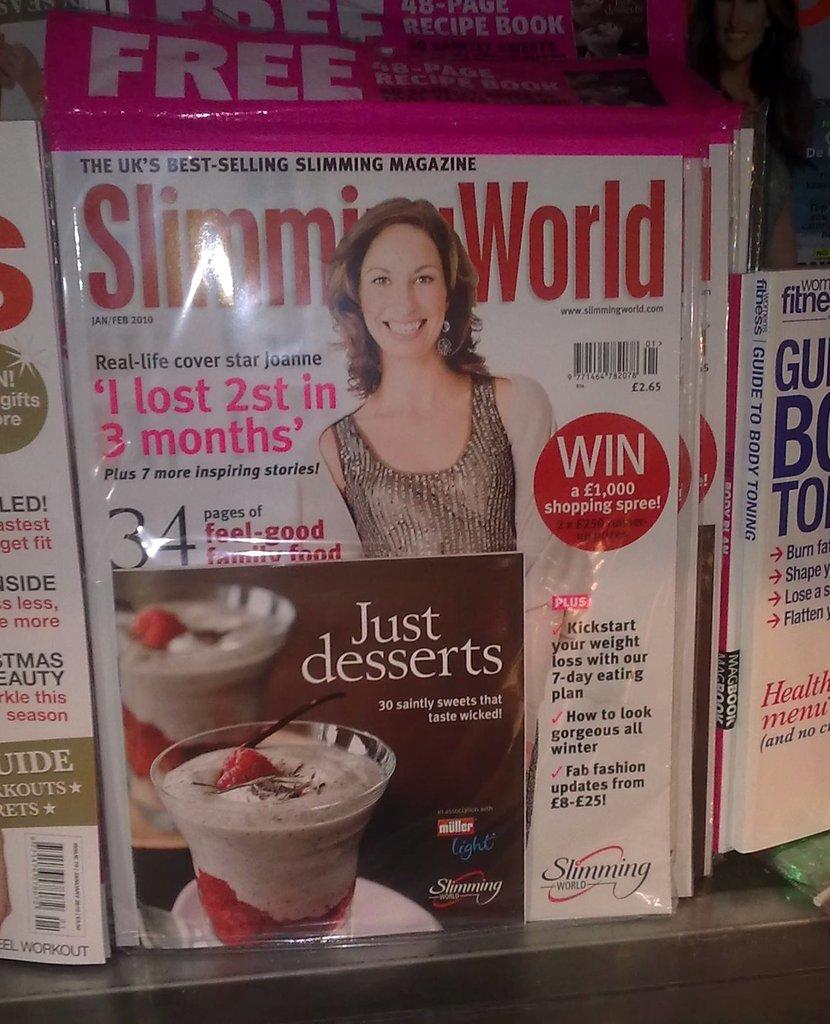What do the bright pink letters say?
Provide a short and direct response. I lost 2st in 3 months. 